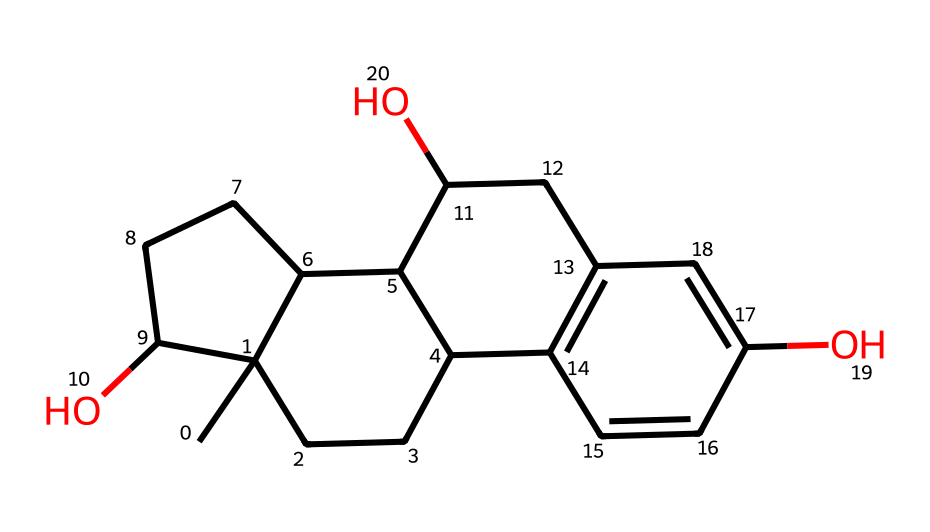What is the molecular formula of estradiol? To determine the molecular formula of estradiol from its SMILES representation, identify the number of each type of atom present in the structure. By analyzing the SMILES, the counts reveal that there are 18 carbon atoms (C), 24 hydrogen atoms (H), and 2 oxygen atoms (O), leading to the formula C18H24O2.
Answer: C18H24O2 How many hydroxyl (OH) groups are present in the structure? In the provided SMILES, the 'O' atoms represent oxygen, and the presence of 'OH' groups can be traced by looking for carbon atoms directly connected to these 'O' atoms. The SMILES reveals that there are two 'O' atoms that connect to two different carbon atoms, indicating the presence of two hydroxyl groups.
Answer: 2 What type of chemical compound is estradiol classified as? Estradiol, based on its structure and functional groups, is a steroid hormone, which is classified as a phenolic compound due to the presence of aromatic rings and hydroxyl groups.
Answer: steroid How many rings are present in the estradiol structure? In the chemical structure indicated by the SMILES, the rings can be counted by analyzing the connections and cyclical patterns in the structure. Upon examining, there are four interconnected rings which are characteristic of steroid hormones.
Answer: 4 Are there any double bonds in estradiol? To find double bonds in the chemical structure, look for '=' symbols within the SMILES representation. The presence of such symbols indicates that there are double bonds between the respective carbon atoms. The analysis shows several double bonds in the aromatic rings and other parts of the structure.
Answer: yes What is the primary function of estradiol in hormone therapy? Estradiol is primarily used in hormone therapy to alleviate symptoms associated with menopause and hormonal imbalances, influencing various physiological processes such as reproductive functions.
Answer: alleviate symptoms 